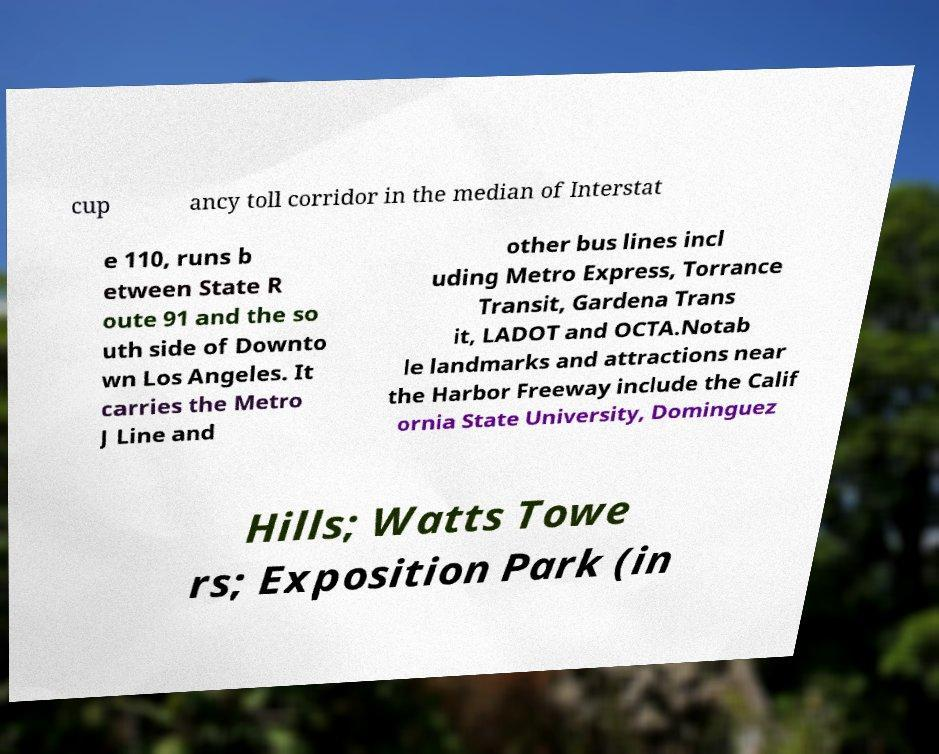Could you assist in decoding the text presented in this image and type it out clearly? cup ancy toll corridor in the median of Interstat e 110, runs b etween State R oute 91 and the so uth side of Downto wn Los Angeles. It carries the Metro J Line and other bus lines incl uding Metro Express, Torrance Transit, Gardena Trans it, LADOT and OCTA.Notab le landmarks and attractions near the Harbor Freeway include the Calif ornia State University, Dominguez Hills; Watts Towe rs; Exposition Park (in 